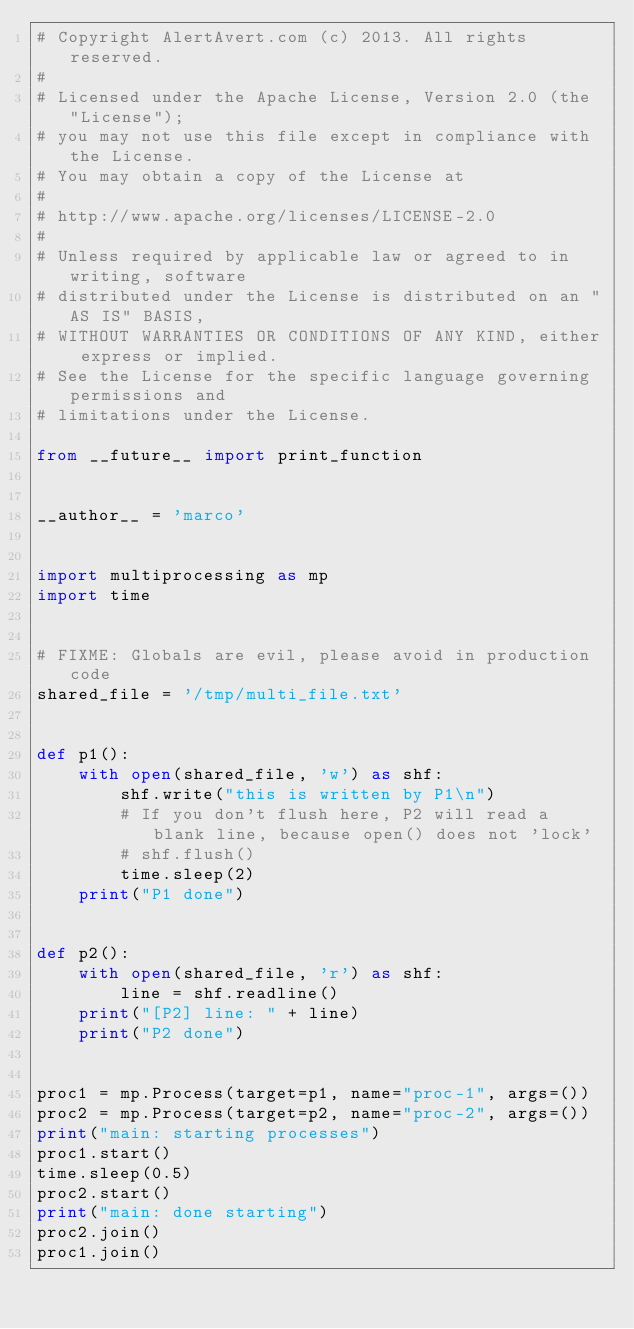<code> <loc_0><loc_0><loc_500><loc_500><_Python_># Copyright AlertAvert.com (c) 2013. All rights reserved.
#
# Licensed under the Apache License, Version 2.0 (the "License");
# you may not use this file except in compliance with the License.
# You may obtain a copy of the License at
#
# http://www.apache.org/licenses/LICENSE-2.0
#
# Unless required by applicable law or agreed to in writing, software
# distributed under the License is distributed on an "AS IS" BASIS,
# WITHOUT WARRANTIES OR CONDITIONS OF ANY KIND, either express or implied.
# See the License for the specific language governing permissions and
# limitations under the License.

from __future__ import print_function


__author__ = 'marco'


import multiprocessing as mp
import time


# FIXME: Globals are evil, please avoid in production code
shared_file = '/tmp/multi_file.txt'


def p1():
    with open(shared_file, 'w') as shf:
        shf.write("this is written by P1\n")
        # If you don't flush here, P2 will read a blank line, because open() does not 'lock'
        # shf.flush()
        time.sleep(2)
    print("P1 done")


def p2():
    with open(shared_file, 'r') as shf:
        line = shf.readline()
    print("[P2] line: " + line)
    print("P2 done")


proc1 = mp.Process(target=p1, name="proc-1", args=())
proc2 = mp.Process(target=p2, name="proc-2", args=())
print("main: starting processes")
proc1.start()
time.sleep(0.5)
proc2.start()
print("main: done starting")
proc2.join()
proc1.join()

</code> 